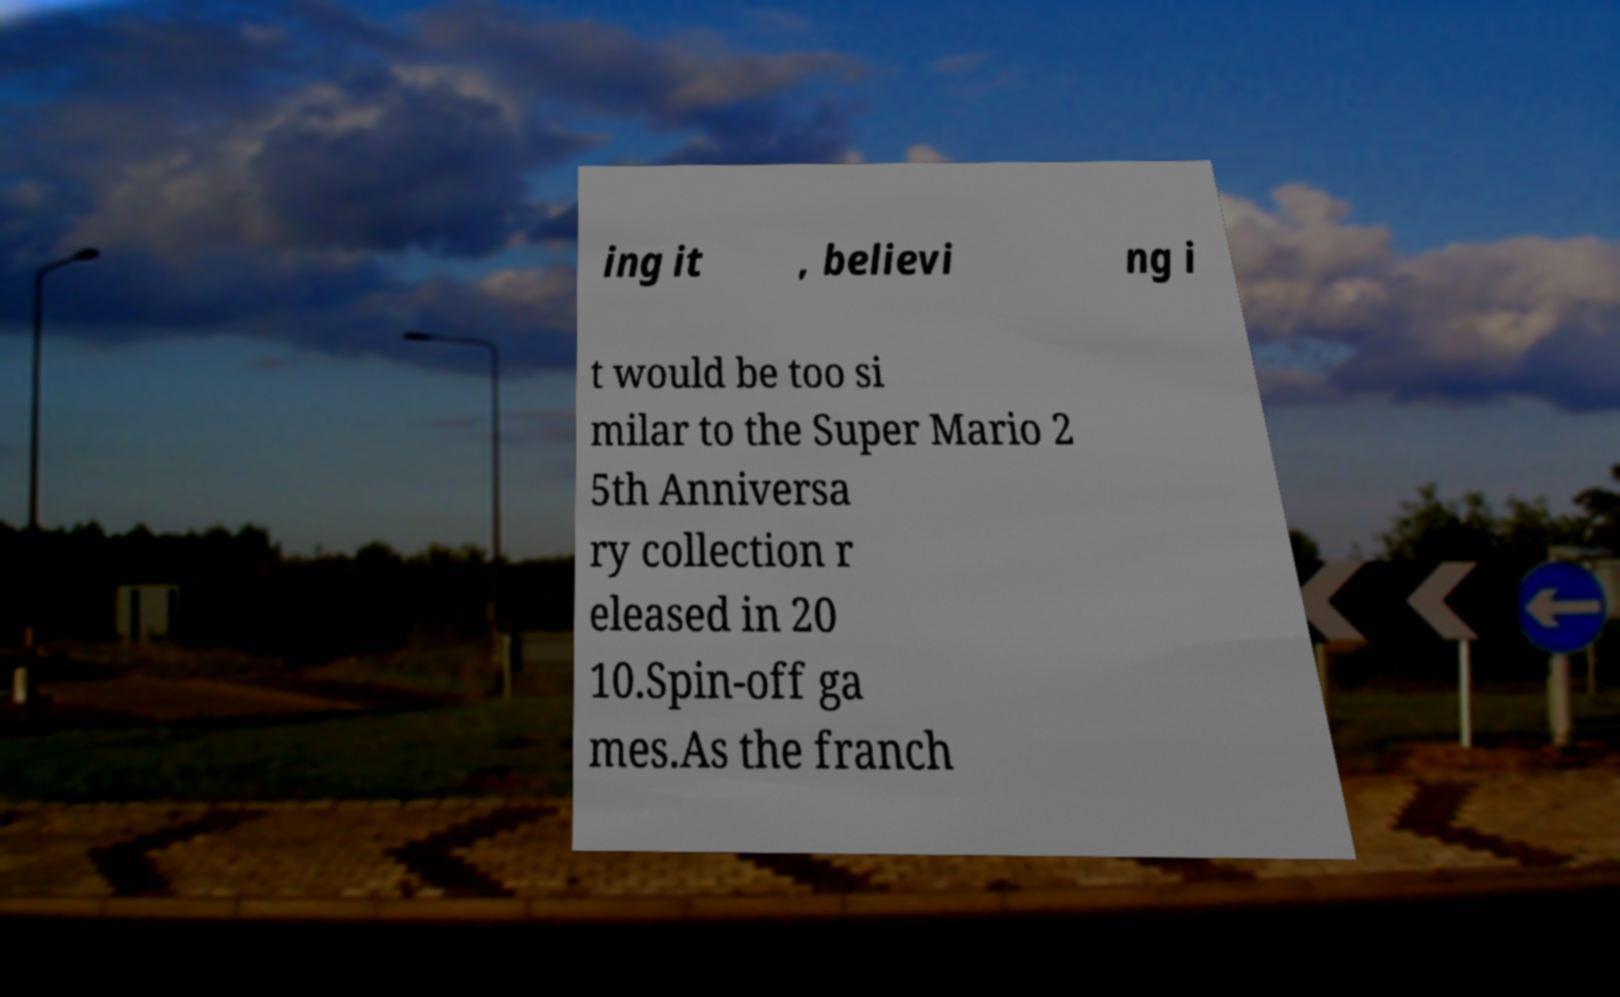Please identify and transcribe the text found in this image. ing it , believi ng i t would be too si milar to the Super Mario 2 5th Anniversa ry collection r eleased in 20 10.Spin-off ga mes.As the franch 